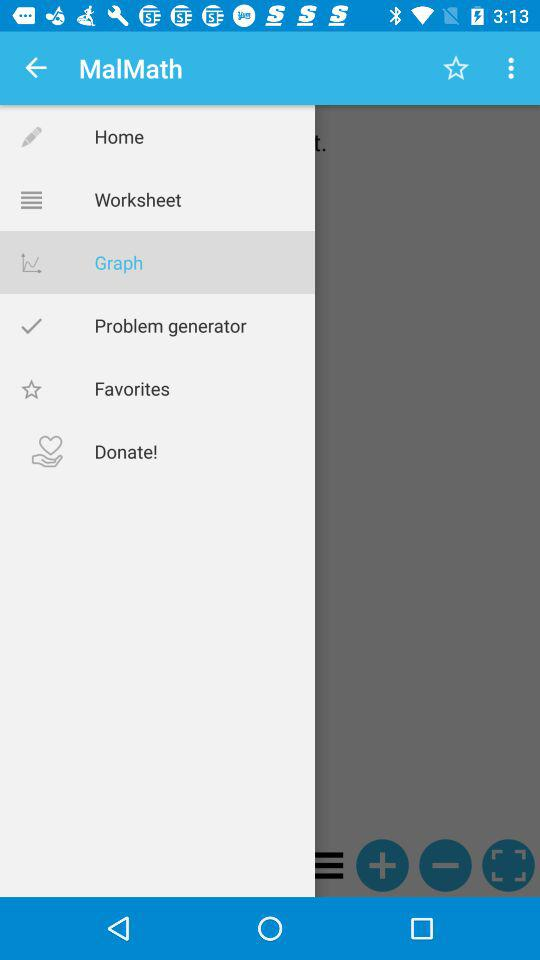How many notifications are there in "Favorites"?
When the provided information is insufficient, respond with <no answer>. <no answer> 